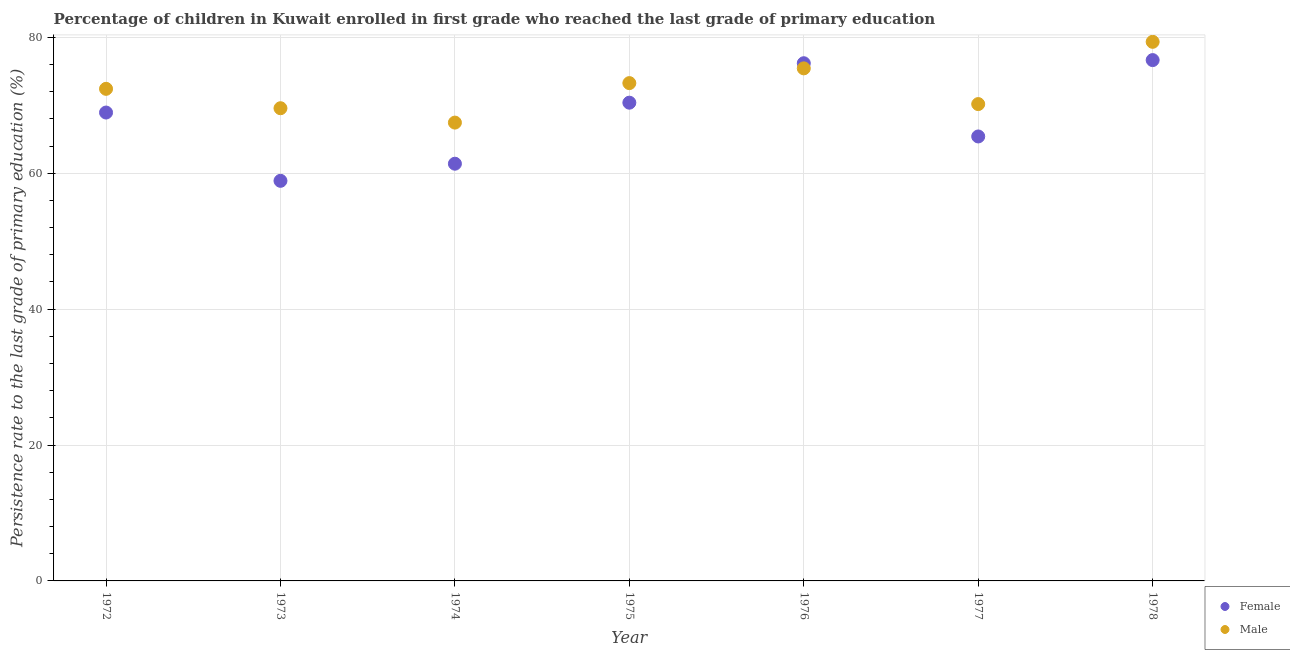How many different coloured dotlines are there?
Provide a short and direct response. 2. Is the number of dotlines equal to the number of legend labels?
Make the answer very short. Yes. What is the persistence rate of female students in 1974?
Offer a terse response. 61.4. Across all years, what is the maximum persistence rate of female students?
Ensure brevity in your answer.  76.65. Across all years, what is the minimum persistence rate of female students?
Give a very brief answer. 58.88. In which year was the persistence rate of female students maximum?
Provide a short and direct response. 1978. In which year was the persistence rate of male students minimum?
Make the answer very short. 1974. What is the total persistence rate of male students in the graph?
Make the answer very short. 507.63. What is the difference between the persistence rate of male students in 1974 and that in 1976?
Provide a short and direct response. -7.98. What is the difference between the persistence rate of male students in 1978 and the persistence rate of female students in 1976?
Make the answer very short. 3.15. What is the average persistence rate of male students per year?
Your answer should be very brief. 72.52. In the year 1976, what is the difference between the persistence rate of female students and persistence rate of male students?
Offer a terse response. 0.76. In how many years, is the persistence rate of female students greater than 12 %?
Make the answer very short. 7. What is the ratio of the persistence rate of female students in 1975 to that in 1977?
Your response must be concise. 1.08. What is the difference between the highest and the second highest persistence rate of male students?
Ensure brevity in your answer.  3.91. What is the difference between the highest and the lowest persistence rate of female students?
Make the answer very short. 17.77. In how many years, is the persistence rate of male students greater than the average persistence rate of male students taken over all years?
Provide a short and direct response. 3. How many dotlines are there?
Keep it short and to the point. 2. Does the graph contain any zero values?
Offer a very short reply. No. How many legend labels are there?
Provide a succinct answer. 2. How are the legend labels stacked?
Make the answer very short. Vertical. What is the title of the graph?
Your answer should be very brief. Percentage of children in Kuwait enrolled in first grade who reached the last grade of primary education. What is the label or title of the X-axis?
Provide a short and direct response. Year. What is the label or title of the Y-axis?
Offer a terse response. Persistence rate to the last grade of primary education (%). What is the Persistence rate to the last grade of primary education (%) in Female in 1972?
Offer a terse response. 68.93. What is the Persistence rate to the last grade of primary education (%) of Male in 1972?
Offer a very short reply. 72.42. What is the Persistence rate to the last grade of primary education (%) of Female in 1973?
Make the answer very short. 58.88. What is the Persistence rate to the last grade of primary education (%) in Male in 1973?
Your answer should be compact. 69.56. What is the Persistence rate to the last grade of primary education (%) of Female in 1974?
Offer a terse response. 61.4. What is the Persistence rate to the last grade of primary education (%) of Male in 1974?
Your answer should be compact. 67.45. What is the Persistence rate to the last grade of primary education (%) in Female in 1975?
Keep it short and to the point. 70.38. What is the Persistence rate to the last grade of primary education (%) in Male in 1975?
Offer a very short reply. 73.26. What is the Persistence rate to the last grade of primary education (%) of Female in 1976?
Your answer should be compact. 76.19. What is the Persistence rate to the last grade of primary education (%) of Male in 1976?
Your response must be concise. 75.43. What is the Persistence rate to the last grade of primary education (%) of Female in 1977?
Your response must be concise. 65.41. What is the Persistence rate to the last grade of primary education (%) of Male in 1977?
Your response must be concise. 70.17. What is the Persistence rate to the last grade of primary education (%) in Female in 1978?
Your response must be concise. 76.65. What is the Persistence rate to the last grade of primary education (%) in Male in 1978?
Keep it short and to the point. 79.34. Across all years, what is the maximum Persistence rate to the last grade of primary education (%) of Female?
Keep it short and to the point. 76.65. Across all years, what is the maximum Persistence rate to the last grade of primary education (%) in Male?
Offer a very short reply. 79.34. Across all years, what is the minimum Persistence rate to the last grade of primary education (%) of Female?
Keep it short and to the point. 58.88. Across all years, what is the minimum Persistence rate to the last grade of primary education (%) of Male?
Give a very brief answer. 67.45. What is the total Persistence rate to the last grade of primary education (%) in Female in the graph?
Your answer should be very brief. 477.83. What is the total Persistence rate to the last grade of primary education (%) in Male in the graph?
Offer a terse response. 507.63. What is the difference between the Persistence rate to the last grade of primary education (%) of Female in 1972 and that in 1973?
Offer a terse response. 10.05. What is the difference between the Persistence rate to the last grade of primary education (%) in Male in 1972 and that in 1973?
Your answer should be compact. 2.85. What is the difference between the Persistence rate to the last grade of primary education (%) in Female in 1972 and that in 1974?
Offer a very short reply. 7.53. What is the difference between the Persistence rate to the last grade of primary education (%) of Male in 1972 and that in 1974?
Your response must be concise. 4.97. What is the difference between the Persistence rate to the last grade of primary education (%) in Female in 1972 and that in 1975?
Your answer should be very brief. -1.45. What is the difference between the Persistence rate to the last grade of primary education (%) of Male in 1972 and that in 1975?
Your answer should be very brief. -0.84. What is the difference between the Persistence rate to the last grade of primary education (%) of Female in 1972 and that in 1976?
Your answer should be compact. -7.26. What is the difference between the Persistence rate to the last grade of primary education (%) of Male in 1972 and that in 1976?
Provide a short and direct response. -3.01. What is the difference between the Persistence rate to the last grade of primary education (%) in Female in 1972 and that in 1977?
Make the answer very short. 3.52. What is the difference between the Persistence rate to the last grade of primary education (%) of Male in 1972 and that in 1977?
Make the answer very short. 2.24. What is the difference between the Persistence rate to the last grade of primary education (%) in Female in 1972 and that in 1978?
Make the answer very short. -7.72. What is the difference between the Persistence rate to the last grade of primary education (%) of Male in 1972 and that in 1978?
Offer a terse response. -6.92. What is the difference between the Persistence rate to the last grade of primary education (%) in Female in 1973 and that in 1974?
Offer a terse response. -2.52. What is the difference between the Persistence rate to the last grade of primary education (%) of Male in 1973 and that in 1974?
Give a very brief answer. 2.12. What is the difference between the Persistence rate to the last grade of primary education (%) of Female in 1973 and that in 1975?
Give a very brief answer. -11.5. What is the difference between the Persistence rate to the last grade of primary education (%) of Male in 1973 and that in 1975?
Offer a terse response. -3.7. What is the difference between the Persistence rate to the last grade of primary education (%) of Female in 1973 and that in 1976?
Ensure brevity in your answer.  -17.31. What is the difference between the Persistence rate to the last grade of primary education (%) in Male in 1973 and that in 1976?
Provide a succinct answer. -5.87. What is the difference between the Persistence rate to the last grade of primary education (%) in Female in 1973 and that in 1977?
Your answer should be compact. -6.53. What is the difference between the Persistence rate to the last grade of primary education (%) of Male in 1973 and that in 1977?
Make the answer very short. -0.61. What is the difference between the Persistence rate to the last grade of primary education (%) of Female in 1973 and that in 1978?
Your answer should be very brief. -17.77. What is the difference between the Persistence rate to the last grade of primary education (%) of Male in 1973 and that in 1978?
Offer a terse response. -9.77. What is the difference between the Persistence rate to the last grade of primary education (%) of Female in 1974 and that in 1975?
Your answer should be compact. -8.98. What is the difference between the Persistence rate to the last grade of primary education (%) of Male in 1974 and that in 1975?
Provide a short and direct response. -5.81. What is the difference between the Persistence rate to the last grade of primary education (%) in Female in 1974 and that in 1976?
Offer a very short reply. -14.79. What is the difference between the Persistence rate to the last grade of primary education (%) of Male in 1974 and that in 1976?
Offer a very short reply. -7.98. What is the difference between the Persistence rate to the last grade of primary education (%) of Female in 1974 and that in 1977?
Provide a succinct answer. -4.01. What is the difference between the Persistence rate to the last grade of primary education (%) in Male in 1974 and that in 1977?
Give a very brief answer. -2.72. What is the difference between the Persistence rate to the last grade of primary education (%) in Female in 1974 and that in 1978?
Offer a terse response. -15.25. What is the difference between the Persistence rate to the last grade of primary education (%) of Male in 1974 and that in 1978?
Provide a short and direct response. -11.89. What is the difference between the Persistence rate to the last grade of primary education (%) in Female in 1975 and that in 1976?
Give a very brief answer. -5.81. What is the difference between the Persistence rate to the last grade of primary education (%) in Male in 1975 and that in 1976?
Your response must be concise. -2.17. What is the difference between the Persistence rate to the last grade of primary education (%) of Female in 1975 and that in 1977?
Ensure brevity in your answer.  4.97. What is the difference between the Persistence rate to the last grade of primary education (%) of Male in 1975 and that in 1977?
Offer a terse response. 3.09. What is the difference between the Persistence rate to the last grade of primary education (%) of Female in 1975 and that in 1978?
Your answer should be compact. -6.27. What is the difference between the Persistence rate to the last grade of primary education (%) in Male in 1975 and that in 1978?
Make the answer very short. -6.08. What is the difference between the Persistence rate to the last grade of primary education (%) in Female in 1976 and that in 1977?
Your answer should be compact. 10.78. What is the difference between the Persistence rate to the last grade of primary education (%) in Male in 1976 and that in 1977?
Give a very brief answer. 5.26. What is the difference between the Persistence rate to the last grade of primary education (%) of Female in 1976 and that in 1978?
Offer a terse response. -0.46. What is the difference between the Persistence rate to the last grade of primary education (%) in Male in 1976 and that in 1978?
Provide a succinct answer. -3.91. What is the difference between the Persistence rate to the last grade of primary education (%) of Female in 1977 and that in 1978?
Provide a succinct answer. -11.24. What is the difference between the Persistence rate to the last grade of primary education (%) in Male in 1977 and that in 1978?
Your response must be concise. -9.16. What is the difference between the Persistence rate to the last grade of primary education (%) of Female in 1972 and the Persistence rate to the last grade of primary education (%) of Male in 1973?
Offer a terse response. -0.64. What is the difference between the Persistence rate to the last grade of primary education (%) in Female in 1972 and the Persistence rate to the last grade of primary education (%) in Male in 1974?
Offer a very short reply. 1.48. What is the difference between the Persistence rate to the last grade of primary education (%) of Female in 1972 and the Persistence rate to the last grade of primary education (%) of Male in 1975?
Provide a succinct answer. -4.33. What is the difference between the Persistence rate to the last grade of primary education (%) of Female in 1972 and the Persistence rate to the last grade of primary education (%) of Male in 1976?
Give a very brief answer. -6.5. What is the difference between the Persistence rate to the last grade of primary education (%) of Female in 1972 and the Persistence rate to the last grade of primary education (%) of Male in 1977?
Give a very brief answer. -1.24. What is the difference between the Persistence rate to the last grade of primary education (%) of Female in 1972 and the Persistence rate to the last grade of primary education (%) of Male in 1978?
Give a very brief answer. -10.41. What is the difference between the Persistence rate to the last grade of primary education (%) in Female in 1973 and the Persistence rate to the last grade of primary education (%) in Male in 1974?
Make the answer very short. -8.57. What is the difference between the Persistence rate to the last grade of primary education (%) of Female in 1973 and the Persistence rate to the last grade of primary education (%) of Male in 1975?
Ensure brevity in your answer.  -14.38. What is the difference between the Persistence rate to the last grade of primary education (%) in Female in 1973 and the Persistence rate to the last grade of primary education (%) in Male in 1976?
Provide a short and direct response. -16.55. What is the difference between the Persistence rate to the last grade of primary education (%) in Female in 1973 and the Persistence rate to the last grade of primary education (%) in Male in 1977?
Make the answer very short. -11.29. What is the difference between the Persistence rate to the last grade of primary education (%) in Female in 1973 and the Persistence rate to the last grade of primary education (%) in Male in 1978?
Offer a very short reply. -20.46. What is the difference between the Persistence rate to the last grade of primary education (%) of Female in 1974 and the Persistence rate to the last grade of primary education (%) of Male in 1975?
Your answer should be compact. -11.86. What is the difference between the Persistence rate to the last grade of primary education (%) in Female in 1974 and the Persistence rate to the last grade of primary education (%) in Male in 1976?
Your answer should be very brief. -14.03. What is the difference between the Persistence rate to the last grade of primary education (%) in Female in 1974 and the Persistence rate to the last grade of primary education (%) in Male in 1977?
Your answer should be compact. -8.78. What is the difference between the Persistence rate to the last grade of primary education (%) of Female in 1974 and the Persistence rate to the last grade of primary education (%) of Male in 1978?
Provide a succinct answer. -17.94. What is the difference between the Persistence rate to the last grade of primary education (%) in Female in 1975 and the Persistence rate to the last grade of primary education (%) in Male in 1976?
Offer a terse response. -5.05. What is the difference between the Persistence rate to the last grade of primary education (%) in Female in 1975 and the Persistence rate to the last grade of primary education (%) in Male in 1977?
Keep it short and to the point. 0.21. What is the difference between the Persistence rate to the last grade of primary education (%) of Female in 1975 and the Persistence rate to the last grade of primary education (%) of Male in 1978?
Your response must be concise. -8.96. What is the difference between the Persistence rate to the last grade of primary education (%) of Female in 1976 and the Persistence rate to the last grade of primary education (%) of Male in 1977?
Provide a short and direct response. 6.01. What is the difference between the Persistence rate to the last grade of primary education (%) in Female in 1976 and the Persistence rate to the last grade of primary education (%) in Male in 1978?
Provide a succinct answer. -3.15. What is the difference between the Persistence rate to the last grade of primary education (%) of Female in 1977 and the Persistence rate to the last grade of primary education (%) of Male in 1978?
Ensure brevity in your answer.  -13.93. What is the average Persistence rate to the last grade of primary education (%) in Female per year?
Offer a terse response. 68.26. What is the average Persistence rate to the last grade of primary education (%) of Male per year?
Your answer should be compact. 72.52. In the year 1972, what is the difference between the Persistence rate to the last grade of primary education (%) of Female and Persistence rate to the last grade of primary education (%) of Male?
Offer a terse response. -3.49. In the year 1973, what is the difference between the Persistence rate to the last grade of primary education (%) of Female and Persistence rate to the last grade of primary education (%) of Male?
Keep it short and to the point. -10.69. In the year 1974, what is the difference between the Persistence rate to the last grade of primary education (%) of Female and Persistence rate to the last grade of primary education (%) of Male?
Offer a very short reply. -6.05. In the year 1975, what is the difference between the Persistence rate to the last grade of primary education (%) of Female and Persistence rate to the last grade of primary education (%) of Male?
Ensure brevity in your answer.  -2.88. In the year 1976, what is the difference between the Persistence rate to the last grade of primary education (%) of Female and Persistence rate to the last grade of primary education (%) of Male?
Offer a terse response. 0.76. In the year 1977, what is the difference between the Persistence rate to the last grade of primary education (%) in Female and Persistence rate to the last grade of primary education (%) in Male?
Offer a very short reply. -4.77. In the year 1978, what is the difference between the Persistence rate to the last grade of primary education (%) in Female and Persistence rate to the last grade of primary education (%) in Male?
Keep it short and to the point. -2.69. What is the ratio of the Persistence rate to the last grade of primary education (%) of Female in 1972 to that in 1973?
Give a very brief answer. 1.17. What is the ratio of the Persistence rate to the last grade of primary education (%) in Male in 1972 to that in 1973?
Offer a terse response. 1.04. What is the ratio of the Persistence rate to the last grade of primary education (%) in Female in 1972 to that in 1974?
Your response must be concise. 1.12. What is the ratio of the Persistence rate to the last grade of primary education (%) in Male in 1972 to that in 1974?
Your response must be concise. 1.07. What is the ratio of the Persistence rate to the last grade of primary education (%) of Female in 1972 to that in 1975?
Keep it short and to the point. 0.98. What is the ratio of the Persistence rate to the last grade of primary education (%) of Male in 1972 to that in 1975?
Provide a succinct answer. 0.99. What is the ratio of the Persistence rate to the last grade of primary education (%) in Female in 1972 to that in 1976?
Your answer should be compact. 0.9. What is the ratio of the Persistence rate to the last grade of primary education (%) of Male in 1972 to that in 1976?
Your answer should be very brief. 0.96. What is the ratio of the Persistence rate to the last grade of primary education (%) in Female in 1972 to that in 1977?
Your answer should be very brief. 1.05. What is the ratio of the Persistence rate to the last grade of primary education (%) of Male in 1972 to that in 1977?
Provide a short and direct response. 1.03. What is the ratio of the Persistence rate to the last grade of primary education (%) in Female in 1972 to that in 1978?
Give a very brief answer. 0.9. What is the ratio of the Persistence rate to the last grade of primary education (%) in Male in 1972 to that in 1978?
Offer a terse response. 0.91. What is the ratio of the Persistence rate to the last grade of primary education (%) in Female in 1973 to that in 1974?
Offer a terse response. 0.96. What is the ratio of the Persistence rate to the last grade of primary education (%) of Male in 1973 to that in 1974?
Keep it short and to the point. 1.03. What is the ratio of the Persistence rate to the last grade of primary education (%) of Female in 1973 to that in 1975?
Offer a very short reply. 0.84. What is the ratio of the Persistence rate to the last grade of primary education (%) of Male in 1973 to that in 1975?
Your answer should be very brief. 0.95. What is the ratio of the Persistence rate to the last grade of primary education (%) in Female in 1973 to that in 1976?
Make the answer very short. 0.77. What is the ratio of the Persistence rate to the last grade of primary education (%) of Male in 1973 to that in 1976?
Make the answer very short. 0.92. What is the ratio of the Persistence rate to the last grade of primary education (%) in Female in 1973 to that in 1977?
Ensure brevity in your answer.  0.9. What is the ratio of the Persistence rate to the last grade of primary education (%) in Male in 1973 to that in 1977?
Offer a very short reply. 0.99. What is the ratio of the Persistence rate to the last grade of primary education (%) in Female in 1973 to that in 1978?
Keep it short and to the point. 0.77. What is the ratio of the Persistence rate to the last grade of primary education (%) of Male in 1973 to that in 1978?
Your response must be concise. 0.88. What is the ratio of the Persistence rate to the last grade of primary education (%) in Female in 1974 to that in 1975?
Offer a very short reply. 0.87. What is the ratio of the Persistence rate to the last grade of primary education (%) of Male in 1974 to that in 1975?
Give a very brief answer. 0.92. What is the ratio of the Persistence rate to the last grade of primary education (%) of Female in 1974 to that in 1976?
Offer a terse response. 0.81. What is the ratio of the Persistence rate to the last grade of primary education (%) in Male in 1974 to that in 1976?
Keep it short and to the point. 0.89. What is the ratio of the Persistence rate to the last grade of primary education (%) in Female in 1974 to that in 1977?
Provide a succinct answer. 0.94. What is the ratio of the Persistence rate to the last grade of primary education (%) in Male in 1974 to that in 1977?
Your response must be concise. 0.96. What is the ratio of the Persistence rate to the last grade of primary education (%) in Female in 1974 to that in 1978?
Your response must be concise. 0.8. What is the ratio of the Persistence rate to the last grade of primary education (%) of Male in 1974 to that in 1978?
Provide a succinct answer. 0.85. What is the ratio of the Persistence rate to the last grade of primary education (%) in Female in 1975 to that in 1976?
Your answer should be compact. 0.92. What is the ratio of the Persistence rate to the last grade of primary education (%) in Male in 1975 to that in 1976?
Provide a short and direct response. 0.97. What is the ratio of the Persistence rate to the last grade of primary education (%) in Female in 1975 to that in 1977?
Provide a short and direct response. 1.08. What is the ratio of the Persistence rate to the last grade of primary education (%) of Male in 1975 to that in 1977?
Ensure brevity in your answer.  1.04. What is the ratio of the Persistence rate to the last grade of primary education (%) of Female in 1975 to that in 1978?
Provide a short and direct response. 0.92. What is the ratio of the Persistence rate to the last grade of primary education (%) of Male in 1975 to that in 1978?
Your answer should be very brief. 0.92. What is the ratio of the Persistence rate to the last grade of primary education (%) in Female in 1976 to that in 1977?
Your response must be concise. 1.16. What is the ratio of the Persistence rate to the last grade of primary education (%) of Male in 1976 to that in 1977?
Provide a succinct answer. 1.07. What is the ratio of the Persistence rate to the last grade of primary education (%) in Female in 1976 to that in 1978?
Offer a very short reply. 0.99. What is the ratio of the Persistence rate to the last grade of primary education (%) in Male in 1976 to that in 1978?
Offer a very short reply. 0.95. What is the ratio of the Persistence rate to the last grade of primary education (%) of Female in 1977 to that in 1978?
Provide a short and direct response. 0.85. What is the ratio of the Persistence rate to the last grade of primary education (%) of Male in 1977 to that in 1978?
Give a very brief answer. 0.88. What is the difference between the highest and the second highest Persistence rate to the last grade of primary education (%) in Female?
Offer a very short reply. 0.46. What is the difference between the highest and the second highest Persistence rate to the last grade of primary education (%) in Male?
Keep it short and to the point. 3.91. What is the difference between the highest and the lowest Persistence rate to the last grade of primary education (%) of Female?
Offer a very short reply. 17.77. What is the difference between the highest and the lowest Persistence rate to the last grade of primary education (%) in Male?
Your response must be concise. 11.89. 